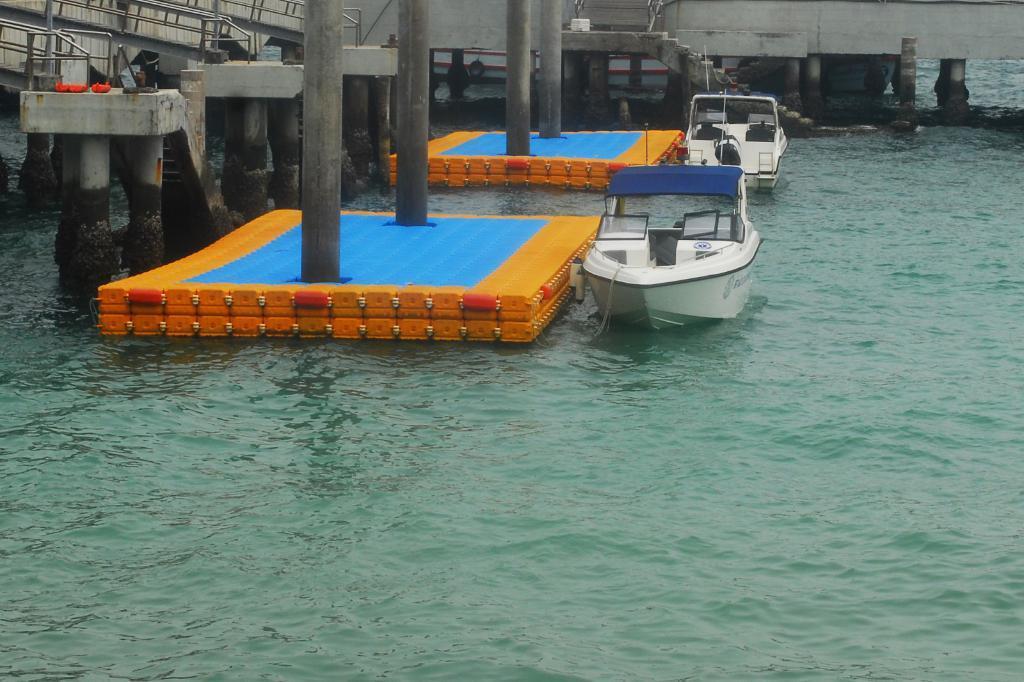What can be seen floating on the water in the image? There are two white boats on water in the image. What colors are present on the surface near the boats? The surface beside the boats is yellow and blue in color. What architectural feature can be seen in the background of the image? There is a staircase in the background of the image. What type of spark can be seen coming from the boats in the image? There is no spark present in the image; the boats are simply floating on water. What kind of drum is being played by the person standing on the boat? There is no person or drum visible in the image. 